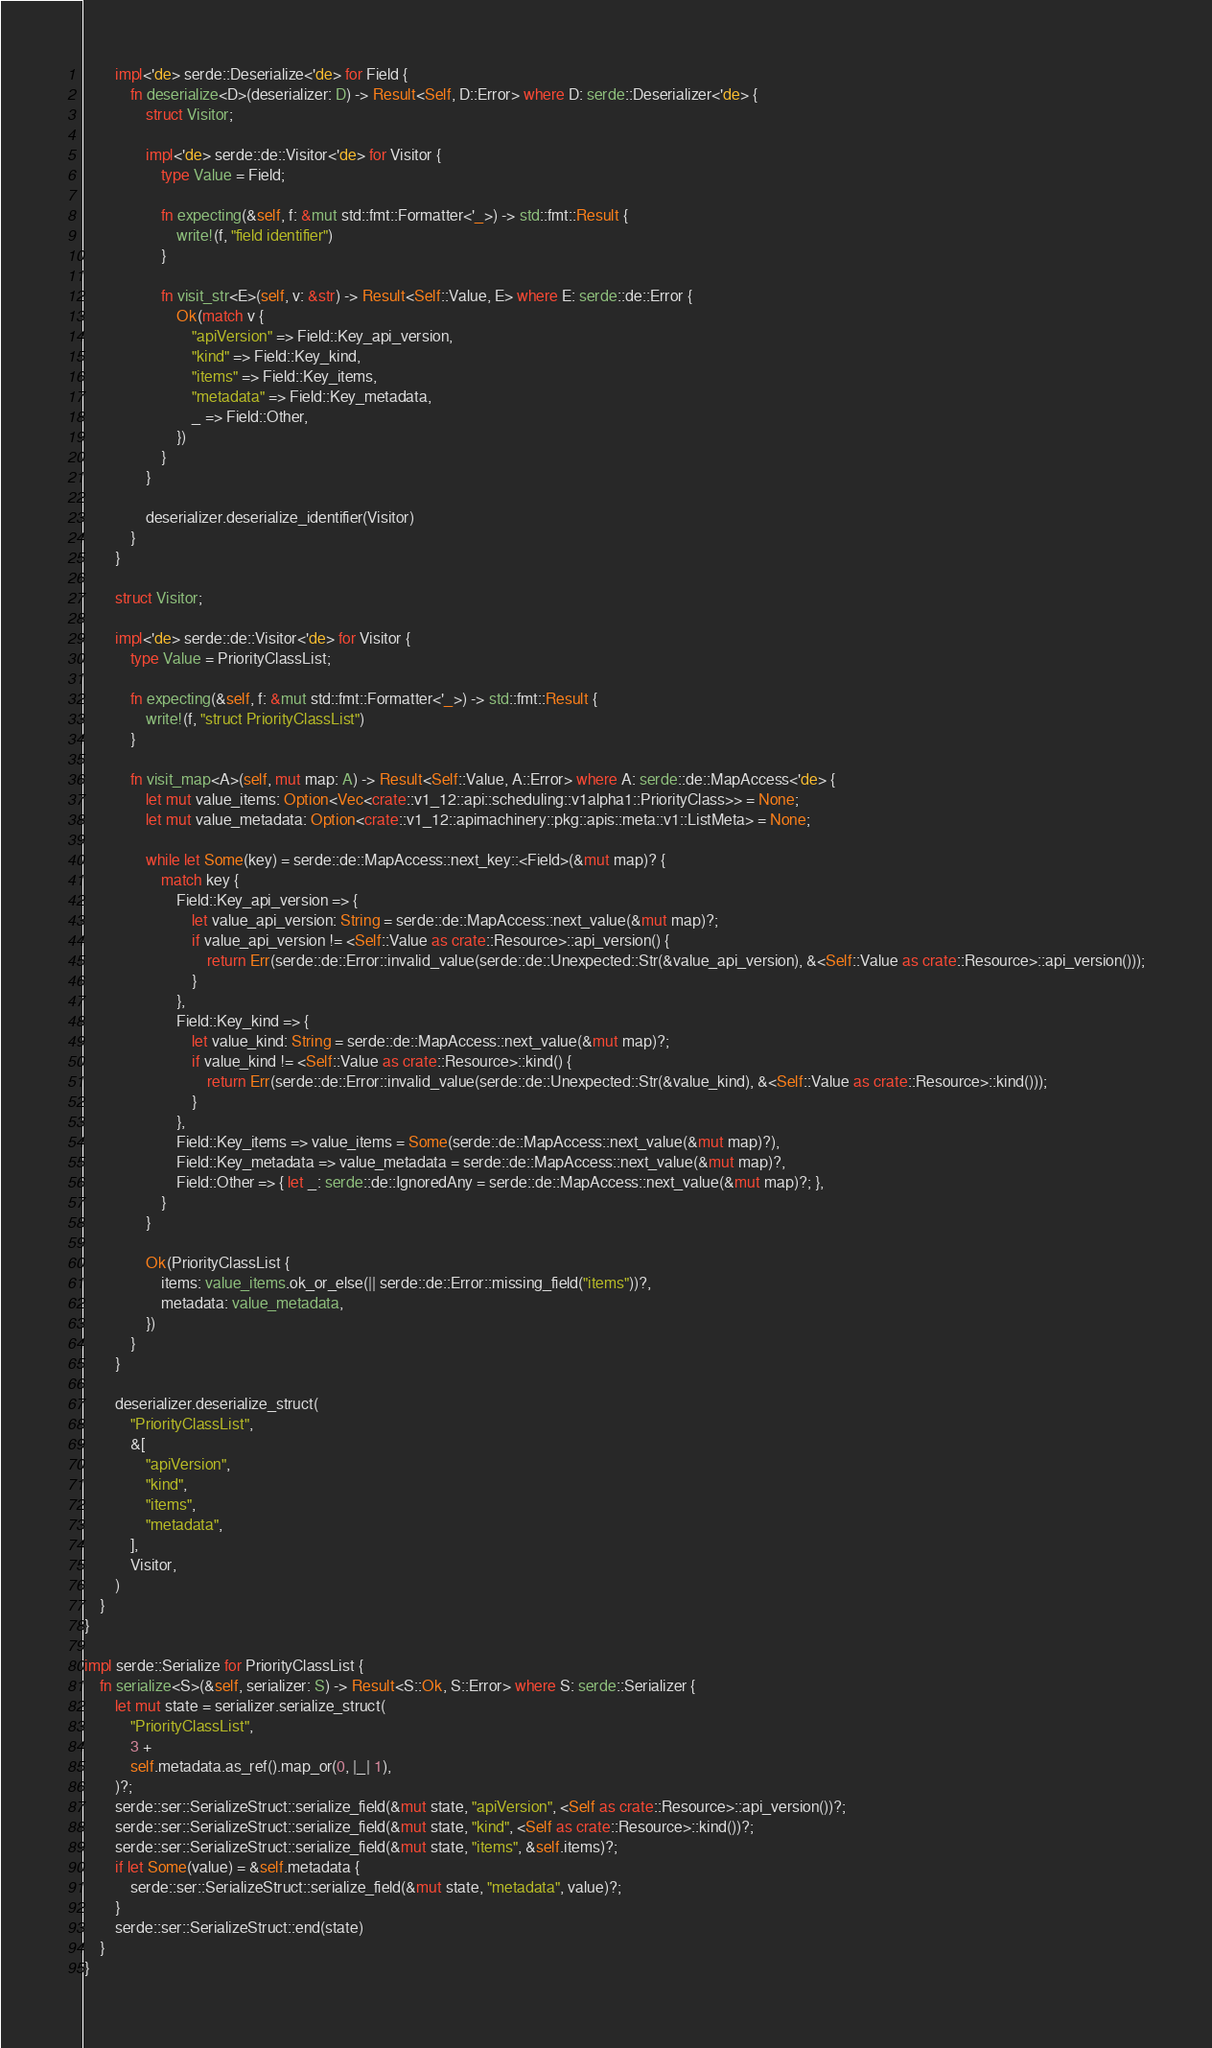Convert code to text. <code><loc_0><loc_0><loc_500><loc_500><_Rust_>        impl<'de> serde::Deserialize<'de> for Field {
            fn deserialize<D>(deserializer: D) -> Result<Self, D::Error> where D: serde::Deserializer<'de> {
                struct Visitor;

                impl<'de> serde::de::Visitor<'de> for Visitor {
                    type Value = Field;

                    fn expecting(&self, f: &mut std::fmt::Formatter<'_>) -> std::fmt::Result {
                        write!(f, "field identifier")
                    }

                    fn visit_str<E>(self, v: &str) -> Result<Self::Value, E> where E: serde::de::Error {
                        Ok(match v {
                            "apiVersion" => Field::Key_api_version,
                            "kind" => Field::Key_kind,
                            "items" => Field::Key_items,
                            "metadata" => Field::Key_metadata,
                            _ => Field::Other,
                        })
                    }
                }

                deserializer.deserialize_identifier(Visitor)
            }
        }

        struct Visitor;

        impl<'de> serde::de::Visitor<'de> for Visitor {
            type Value = PriorityClassList;

            fn expecting(&self, f: &mut std::fmt::Formatter<'_>) -> std::fmt::Result {
                write!(f, "struct PriorityClassList")
            }

            fn visit_map<A>(self, mut map: A) -> Result<Self::Value, A::Error> where A: serde::de::MapAccess<'de> {
                let mut value_items: Option<Vec<crate::v1_12::api::scheduling::v1alpha1::PriorityClass>> = None;
                let mut value_metadata: Option<crate::v1_12::apimachinery::pkg::apis::meta::v1::ListMeta> = None;

                while let Some(key) = serde::de::MapAccess::next_key::<Field>(&mut map)? {
                    match key {
                        Field::Key_api_version => {
                            let value_api_version: String = serde::de::MapAccess::next_value(&mut map)?;
                            if value_api_version != <Self::Value as crate::Resource>::api_version() {
                                return Err(serde::de::Error::invalid_value(serde::de::Unexpected::Str(&value_api_version), &<Self::Value as crate::Resource>::api_version()));
                            }
                        },
                        Field::Key_kind => {
                            let value_kind: String = serde::de::MapAccess::next_value(&mut map)?;
                            if value_kind != <Self::Value as crate::Resource>::kind() {
                                return Err(serde::de::Error::invalid_value(serde::de::Unexpected::Str(&value_kind), &<Self::Value as crate::Resource>::kind()));
                            }
                        },
                        Field::Key_items => value_items = Some(serde::de::MapAccess::next_value(&mut map)?),
                        Field::Key_metadata => value_metadata = serde::de::MapAccess::next_value(&mut map)?,
                        Field::Other => { let _: serde::de::IgnoredAny = serde::de::MapAccess::next_value(&mut map)?; },
                    }
                }

                Ok(PriorityClassList {
                    items: value_items.ok_or_else(|| serde::de::Error::missing_field("items"))?,
                    metadata: value_metadata,
                })
            }
        }

        deserializer.deserialize_struct(
            "PriorityClassList",
            &[
                "apiVersion",
                "kind",
                "items",
                "metadata",
            ],
            Visitor,
        )
    }
}

impl serde::Serialize for PriorityClassList {
    fn serialize<S>(&self, serializer: S) -> Result<S::Ok, S::Error> where S: serde::Serializer {
        let mut state = serializer.serialize_struct(
            "PriorityClassList",
            3 +
            self.metadata.as_ref().map_or(0, |_| 1),
        )?;
        serde::ser::SerializeStruct::serialize_field(&mut state, "apiVersion", <Self as crate::Resource>::api_version())?;
        serde::ser::SerializeStruct::serialize_field(&mut state, "kind", <Self as crate::Resource>::kind())?;
        serde::ser::SerializeStruct::serialize_field(&mut state, "items", &self.items)?;
        if let Some(value) = &self.metadata {
            serde::ser::SerializeStruct::serialize_field(&mut state, "metadata", value)?;
        }
        serde::ser::SerializeStruct::end(state)
    }
}
</code> 